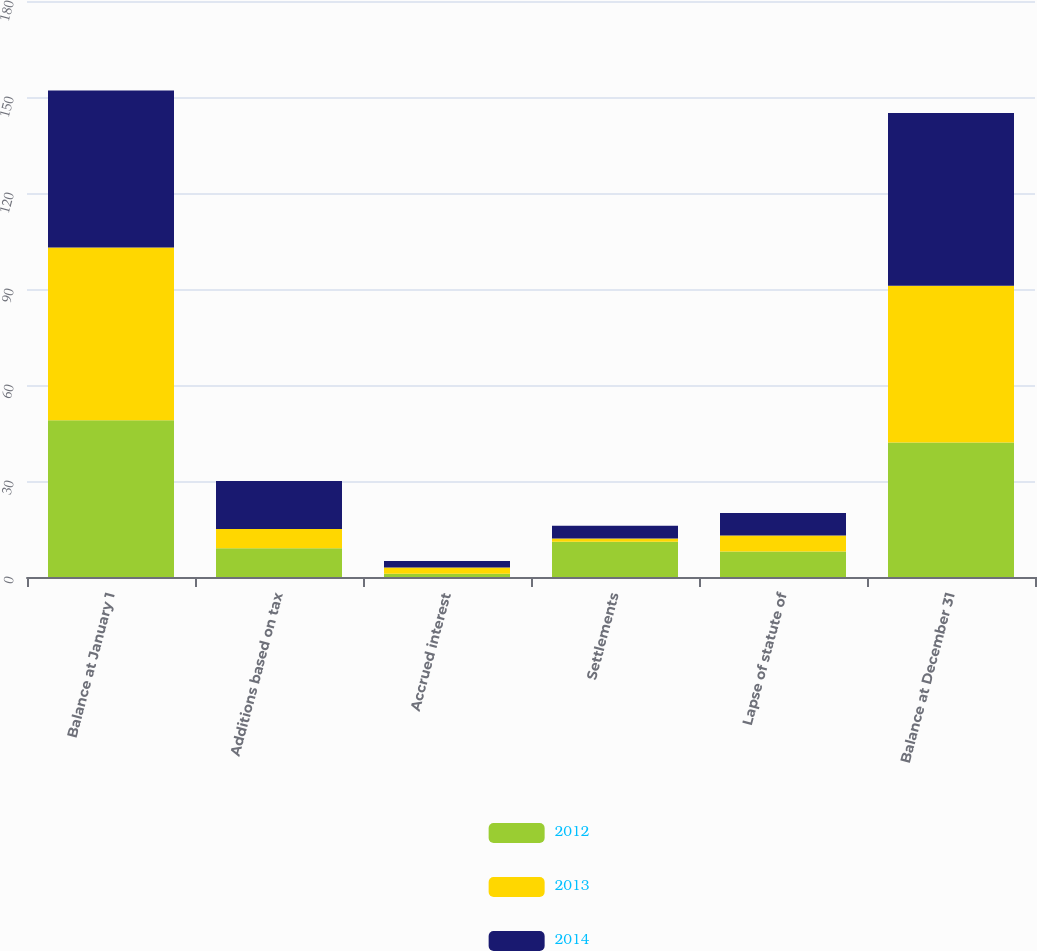Convert chart to OTSL. <chart><loc_0><loc_0><loc_500><loc_500><stacked_bar_chart><ecel><fcel>Balance at January 1<fcel>Additions based on tax<fcel>Accrued interest<fcel>Settlements<fcel>Lapse of statute of<fcel>Balance at December 31<nl><fcel>2012<fcel>49<fcel>9<fcel>1<fcel>11<fcel>8<fcel>42<nl><fcel>2013<fcel>54<fcel>6<fcel>2<fcel>1<fcel>5<fcel>49<nl><fcel>2014<fcel>49<fcel>15<fcel>2<fcel>4<fcel>7<fcel>54<nl></chart> 